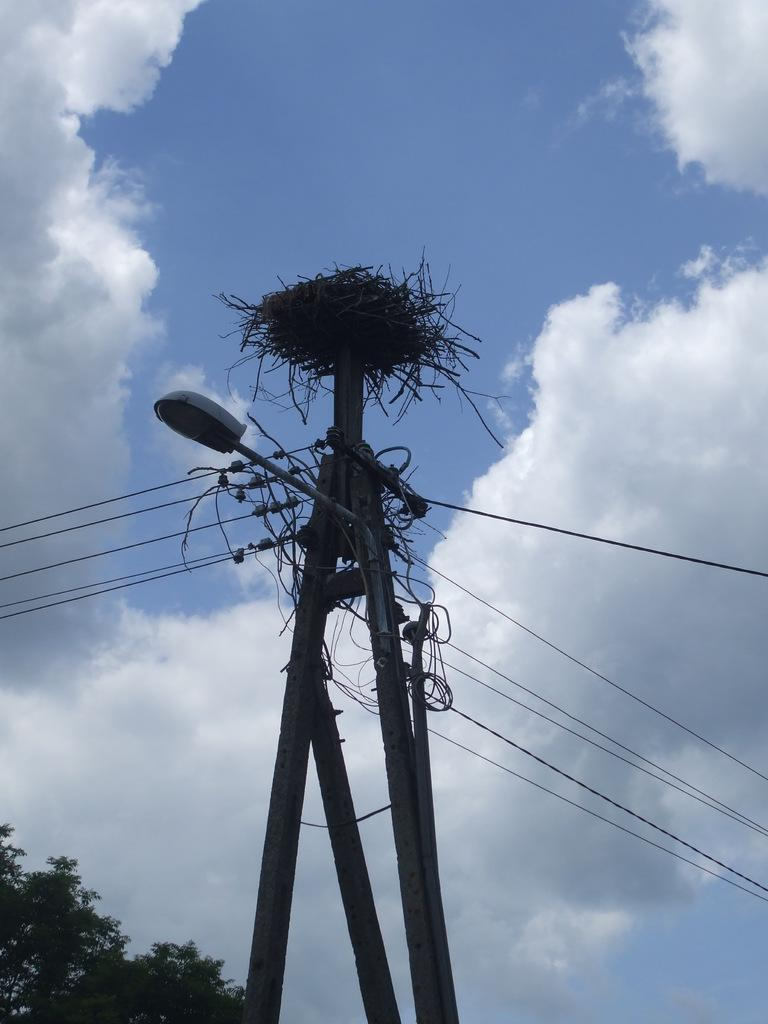What is located in the center of the image? There is a current pole and a street light in the center of the image. What else can be seen in the center of the image? There are wires in the center of the image. Where is the tree located in the image? The tree is at the bottom left corner of the image. What is visible in the background of the image? The sky is visible in the background of the image, and there are clouds in the background as well. What type of reward is hanging from the edge of the current pole in the image? There is no reward hanging from the edge of the current pole in the image; it is a utility pole with wires and a street light. What is used to cover the wires in the image? The wires in the image are not covered; they are visible and attached to the current pole and street light. 